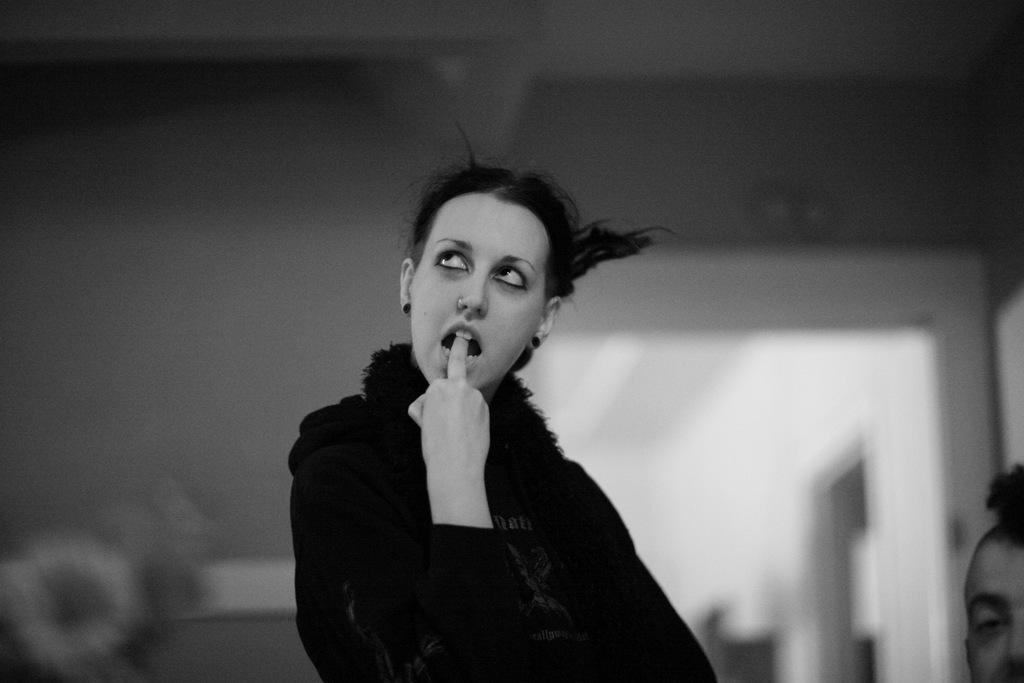How many individuals are present in the image? There are two people in the image. What is the setting of the image? The people are inside a building. What type of wine is being served in the image? There is no wine present in the image; it only features two people inside a building. What type of skirt is the person on the left wearing in the image? There is no skirt visible in the image, as the people are not wearing any clothing that would indicate the presence of a skirt. 